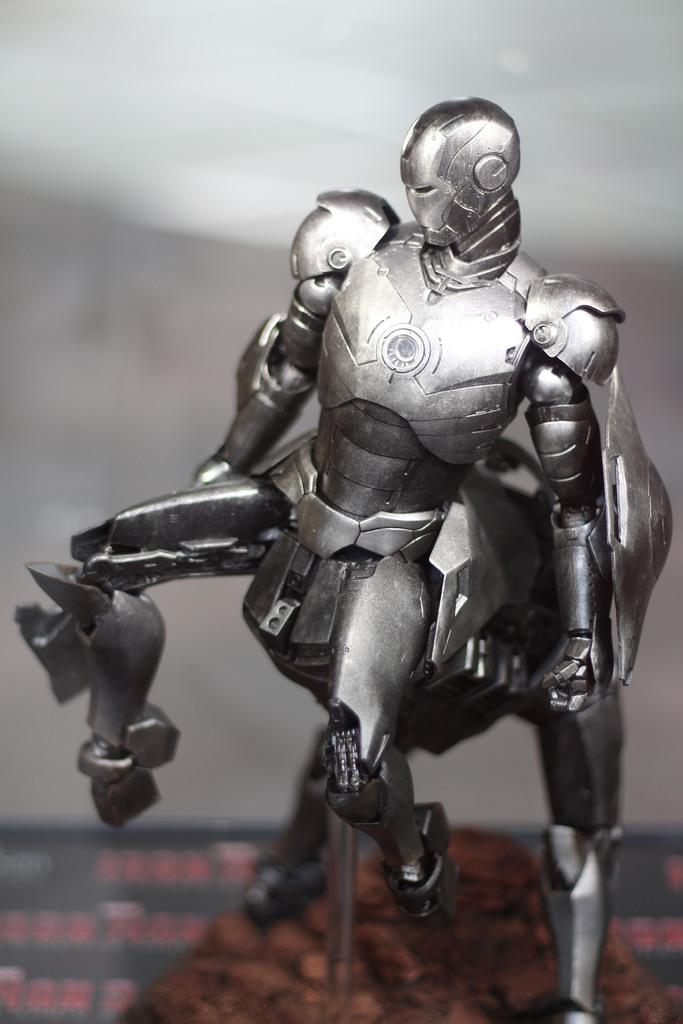What type of toys are present in the image? There are toy robots in the image. What is the surface at the bottom of the image? The surface at the bottom of the image is not described in the provided facts, so we cannot definitively answer this question. How many sheep can be seen grazing in the image? There are no sheep present in the image; it features toy robots. What type of light source is illuminating the toy robots in the image? The provided facts do not mention any light source, so we cannot definitively answer this question. 